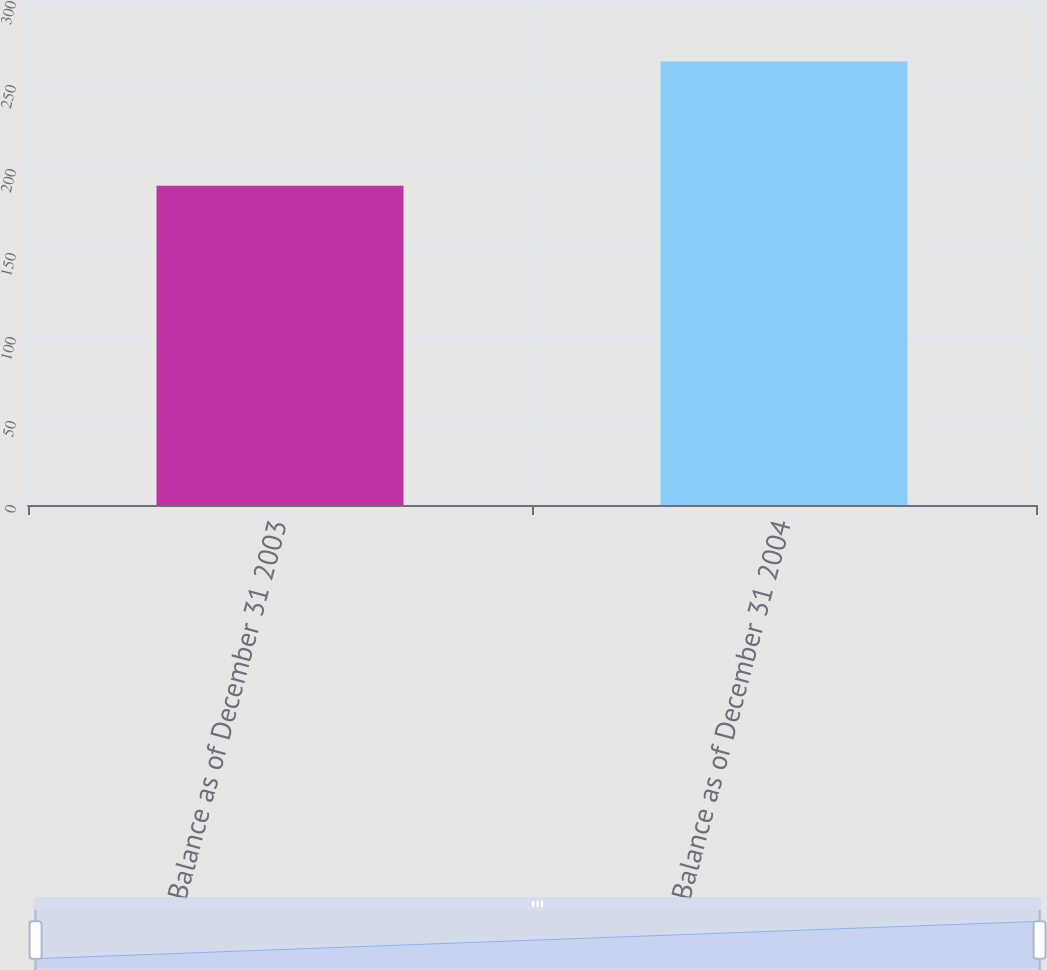Convert chart to OTSL. <chart><loc_0><loc_0><loc_500><loc_500><bar_chart><fcel>Balance as of December 31 2003<fcel>Balance as of December 31 2004<nl><fcel>190<fcel>264<nl></chart> 